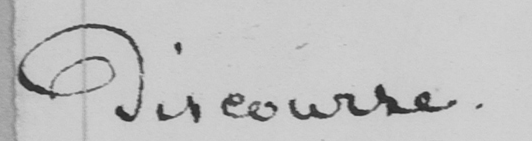What text is written in this handwritten line? discourse . 